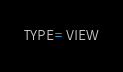Convert code to text. <code><loc_0><loc_0><loc_500><loc_500><_VisualBasic_>TYPE=VIEW</code> 